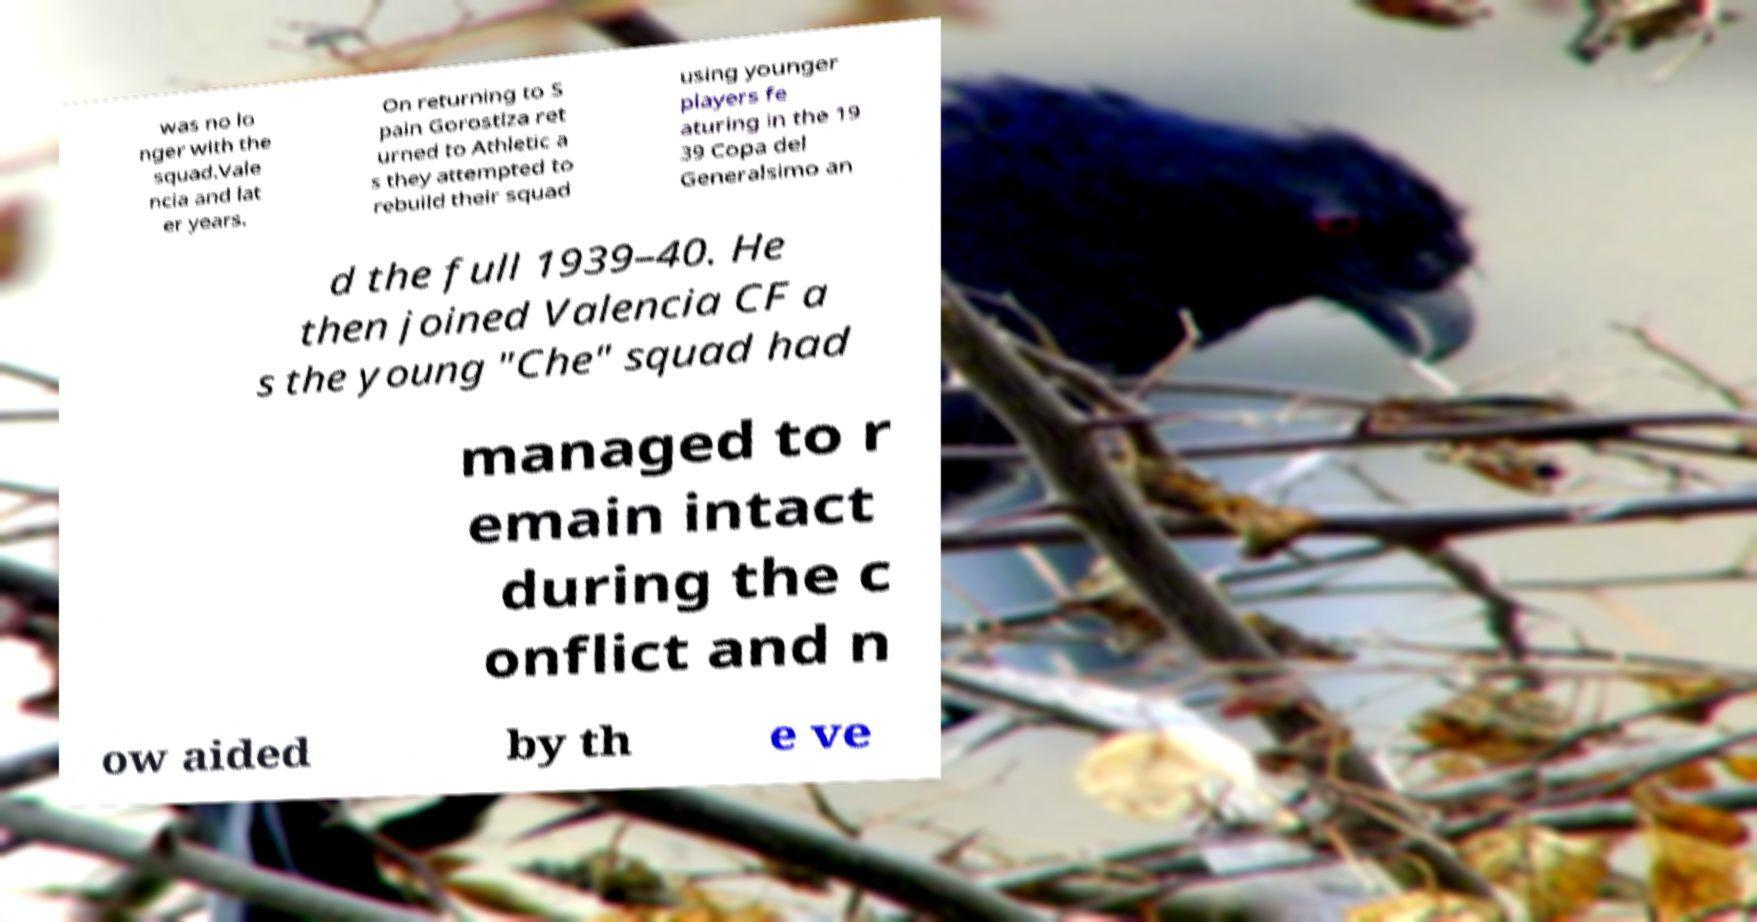Can you read and provide the text displayed in the image?This photo seems to have some interesting text. Can you extract and type it out for me? was no lo nger with the squad.Vale ncia and lat er years. On returning to S pain Gorostiza ret urned to Athletic a s they attempted to rebuild their squad using younger players fe aturing in the 19 39 Copa del Generalsimo an d the full 1939–40. He then joined Valencia CF a s the young "Che" squad had managed to r emain intact during the c onflict and n ow aided by th e ve 